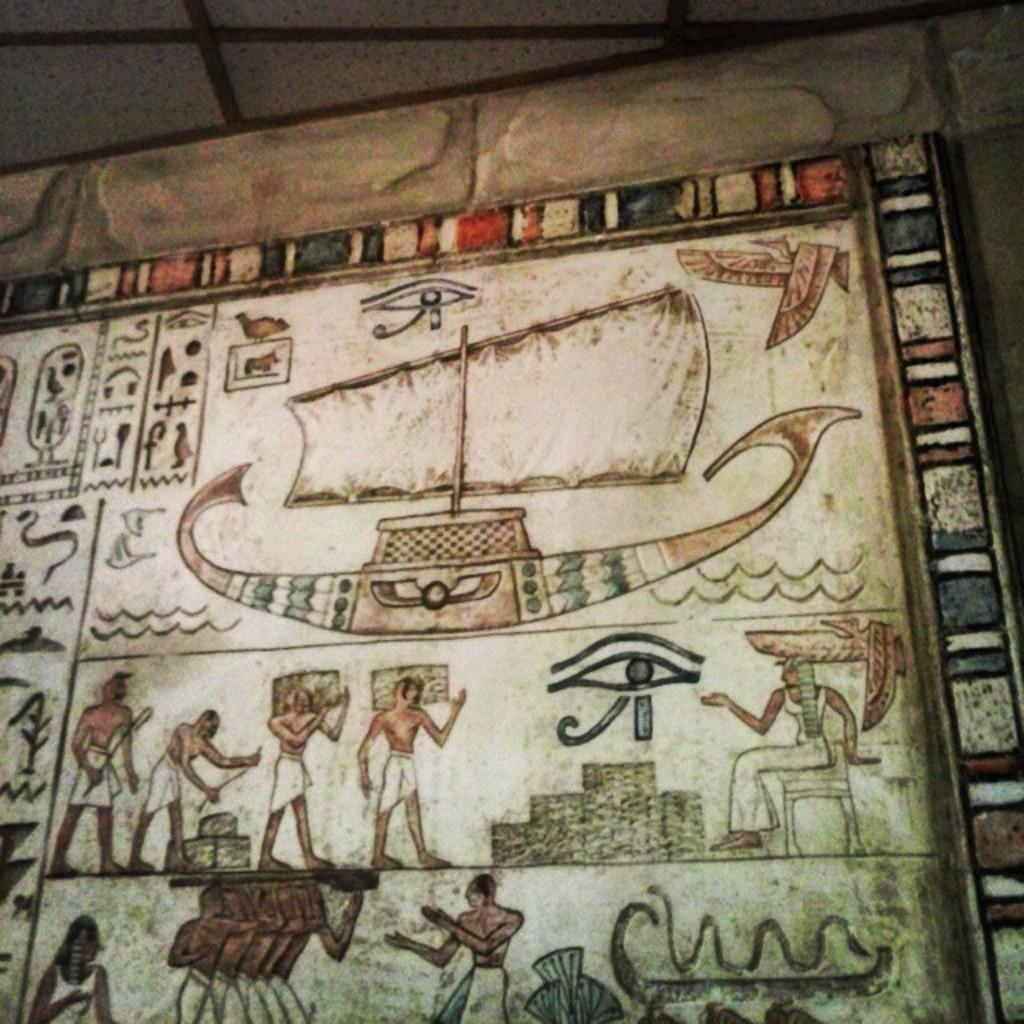What is hanging on the wall in the image? There is a frame with images hanging on the wall. What part of the room can be seen above the frame? There is a ceiling visible in the image. What advice does the manager give to the person's feet in the image? There is no manager or person's feet present in the image; it only features a frame with images hanging on the wall and a visible ceiling. 